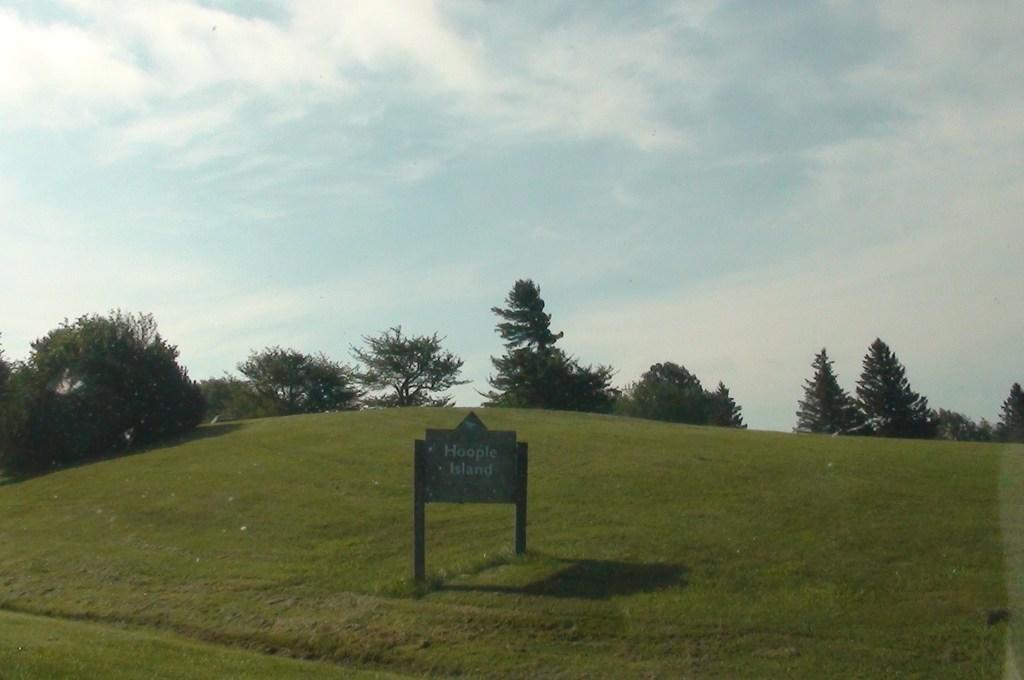In one or two sentences, can you explain what this image depicts? At the bottom of this image, there is a sign board attached to the two poles which are on the ground, on which there are trees and grass. In the background, there are clouds in the sky. 